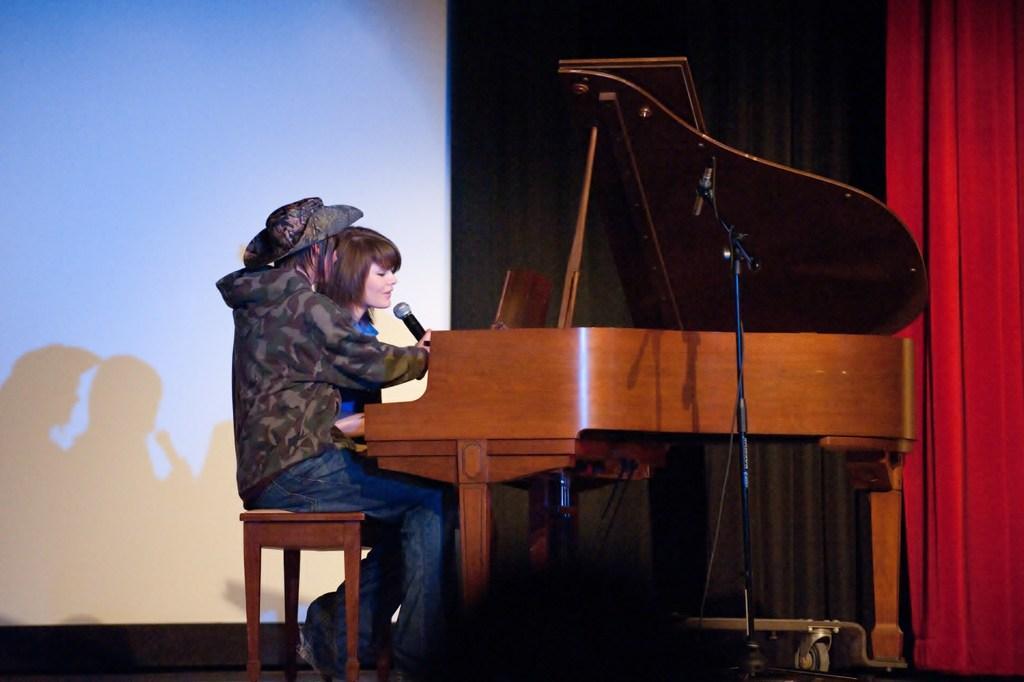Describe this image in one or two sentences. The women wearing blue dress is playing piano and singing in front of a mic and the person beside her is holding a mic. 